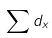<formula> <loc_0><loc_0><loc_500><loc_500>\sum d _ { x }</formula> 